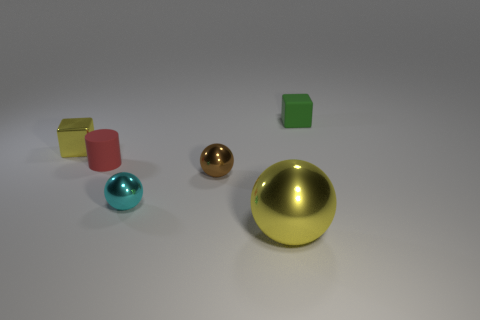There is a yellow object in front of the metallic cube; is there a cylinder behind it?
Provide a succinct answer. Yes. Is there anything else that has the same shape as the red rubber object?
Make the answer very short. No. There is another small metallic thing that is the same shape as the small cyan shiny thing; what is its color?
Keep it short and to the point. Brown. The yellow sphere is what size?
Your answer should be compact. Large. Is the number of small yellow objects in front of the red matte cylinder less than the number of small cyan rubber things?
Give a very brief answer. No. Is the cyan thing made of the same material as the small block in front of the green object?
Give a very brief answer. Yes. There is a tiny rubber thing that is on the left side of the yellow metallic object in front of the yellow block; is there a small thing that is on the right side of it?
Keep it short and to the point. Yes. Is there anything else that has the same size as the yellow ball?
Offer a terse response. No. What is the color of the tiny cube that is made of the same material as the big object?
Ensure brevity in your answer.  Yellow. There is a thing that is right of the tiny brown metallic sphere and left of the small green block; how big is it?
Offer a terse response. Large. 